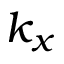<formula> <loc_0><loc_0><loc_500><loc_500>k _ { x }</formula> 